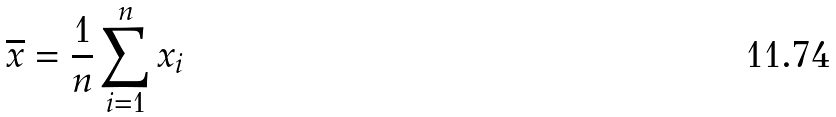<formula> <loc_0><loc_0><loc_500><loc_500>\overline { x } = \frac { 1 } { n } \sum _ { i = 1 } ^ { n } x _ { i }</formula> 